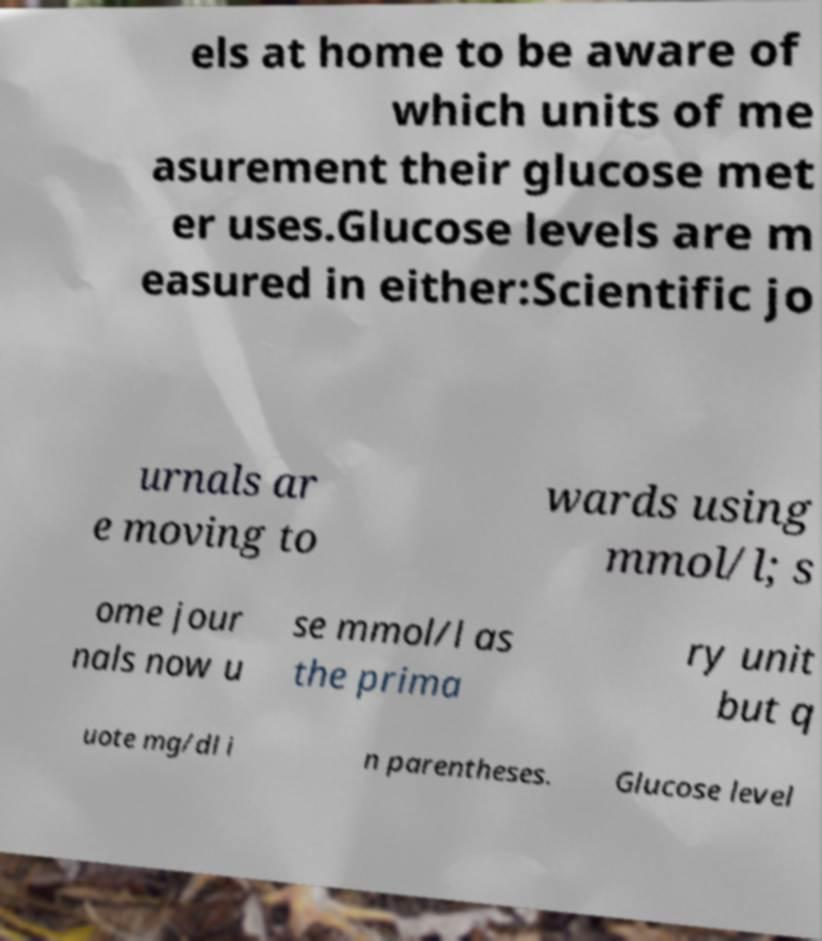Can you read and provide the text displayed in the image?This photo seems to have some interesting text. Can you extract and type it out for me? els at home to be aware of which units of me asurement their glucose met er uses.Glucose levels are m easured in either:Scientific jo urnals ar e moving to wards using mmol/l; s ome jour nals now u se mmol/l as the prima ry unit but q uote mg/dl i n parentheses. Glucose level 